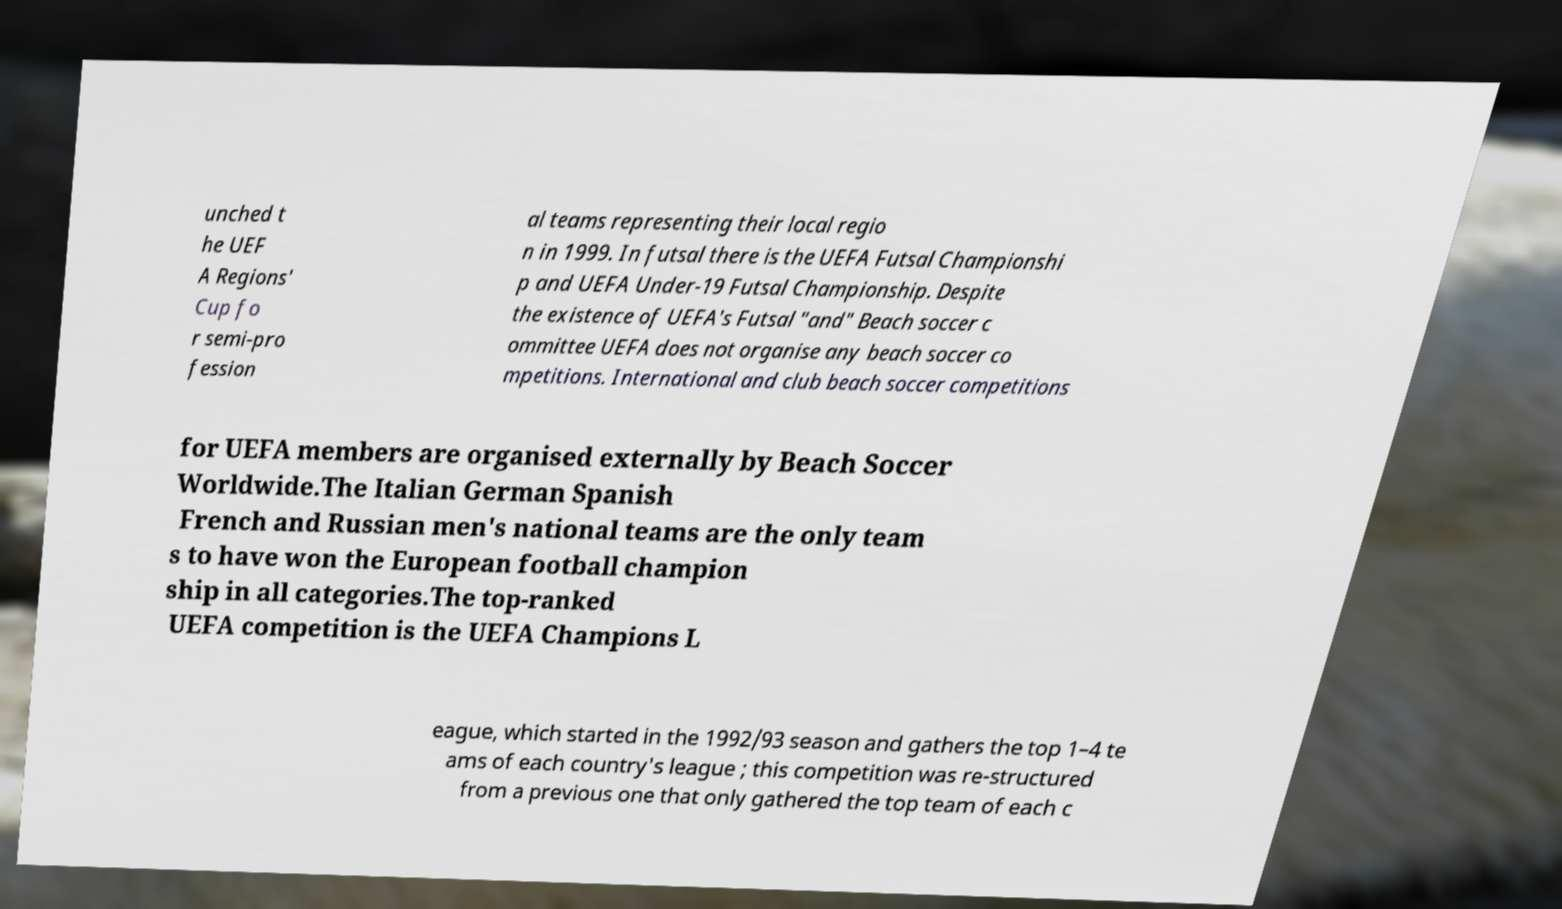Could you assist in decoding the text presented in this image and type it out clearly? unched t he UEF A Regions' Cup fo r semi-pro fession al teams representing their local regio n in 1999. In futsal there is the UEFA Futsal Championshi p and UEFA Under-19 Futsal Championship. Despite the existence of UEFA's Futsal "and" Beach soccer c ommittee UEFA does not organise any beach soccer co mpetitions. International and club beach soccer competitions for UEFA members are organised externally by Beach Soccer Worldwide.The Italian German Spanish French and Russian men's national teams are the only team s to have won the European football champion ship in all categories.The top-ranked UEFA competition is the UEFA Champions L eague, which started in the 1992/93 season and gathers the top 1–4 te ams of each country's league ; this competition was re-structured from a previous one that only gathered the top team of each c 